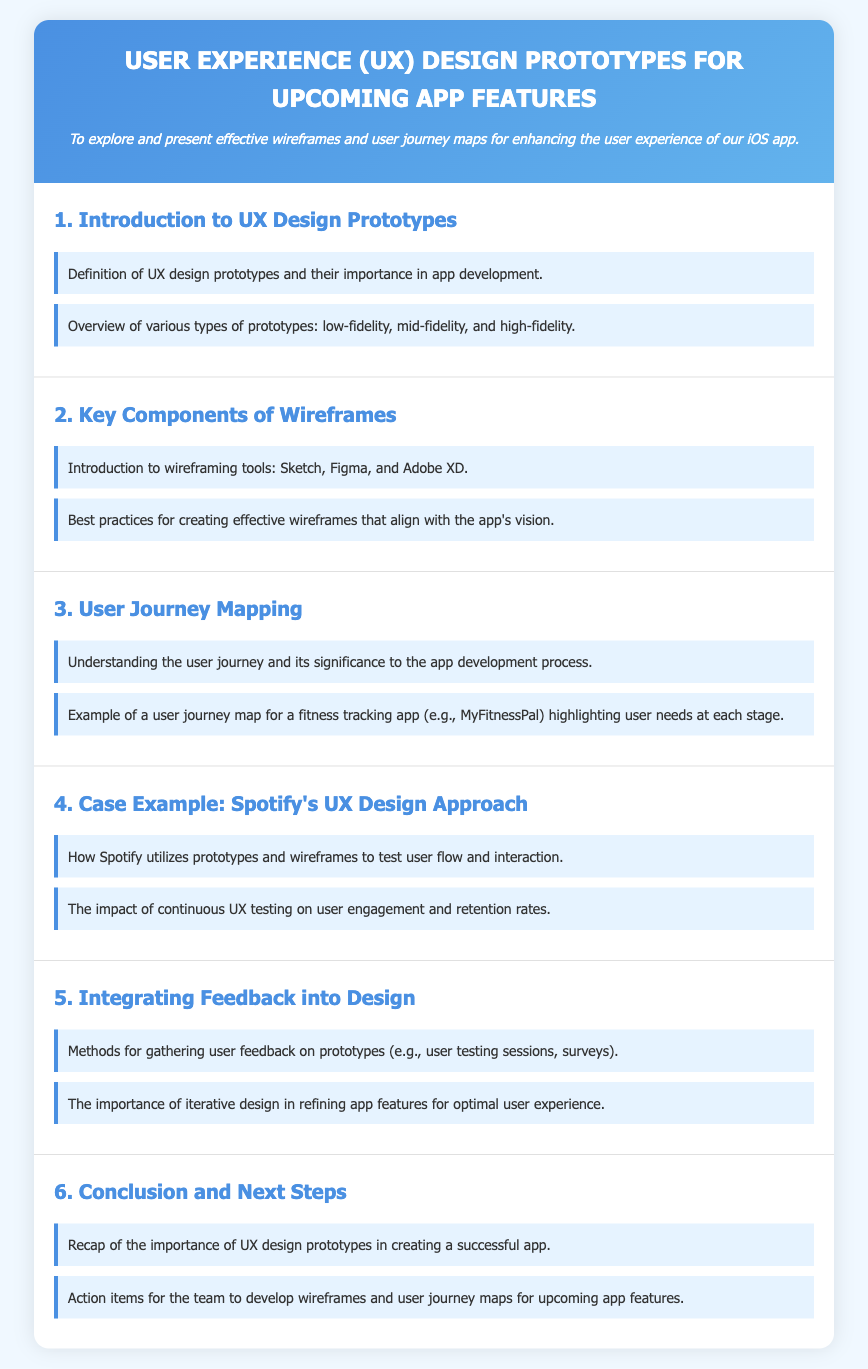What is the purpose of the document? The purpose is stated as exploring and presenting effective wireframes and user journey maps for enhancing the user experience of the iOS app.
Answer: Enhancing user experience of the iOS app How many sections are in the document? The document outlines a total of six sections, each addressing a different aspect of UX design prototypes.
Answer: Six sections What tool is mentioned for wireframing? Sketch, Figma, and Adobe XD are introduced as tools for wireframing in the document.
Answer: Sketch, Figma, and Adobe XD Which app is used as an example for user journey mapping? The document discusses MyFitnessPal as an example of a user journey map in a fitness tracking context.
Answer: MyFitnessPal What is the key point about integrating feedback? The document highlights the importance of gathering user feedback on prototypes through user testing sessions and surveys.
Answer: Gathering user feedback How does Spotify utilize prototypes according to the document? The document states that Spotify utilizes prototypes and wireframes to test user flow and interaction.
Answer: Test user flow and interaction What design approach is emphasized for enhancing user experience? Iterative design is emphasized as crucial for refining app features for optimal user experience.
Answer: Iterative design What does the conclusion recap about UX design prototypes? It recaps the importance of UX design prototypes in creating a successful app.
Answer: Importance in creating a successful app 